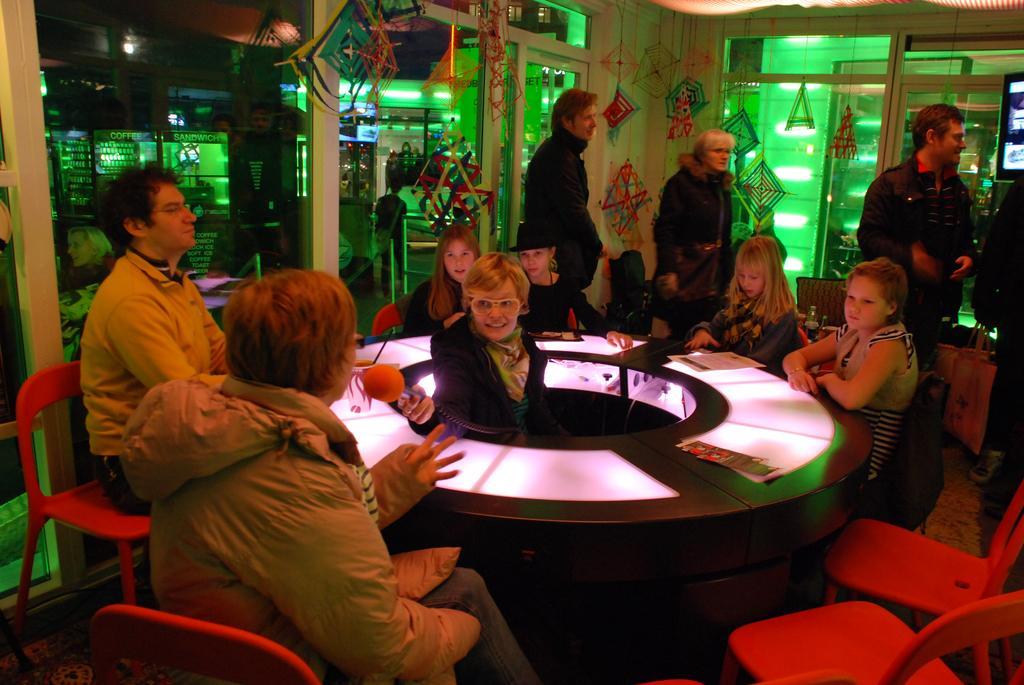Could you give a brief overview of what you see in this image? There are kids, a man and a woman sitting around the table and there is a woman in the middle of the table. The woman who sat on the chair is talking on the mic. They all sat in a room enclosed with glass walls and door. There are several hangings in the room and outside the room there is building, stores and people walking. 